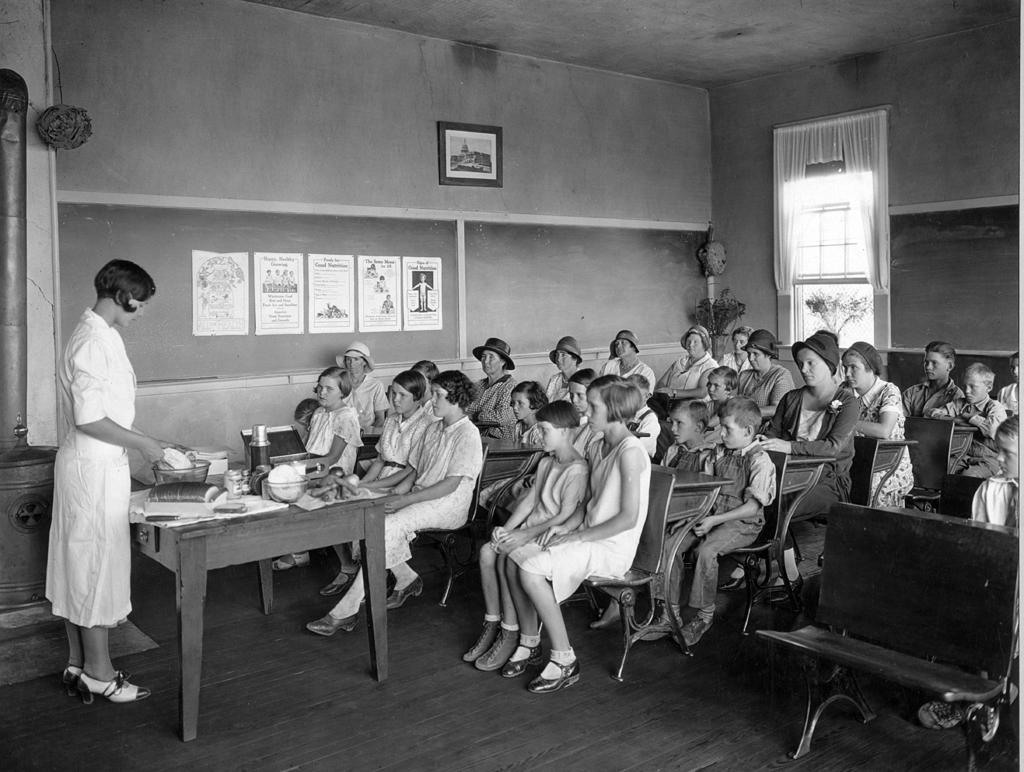What is happening in the image involving a group of people? There is a group of people in the image, and they are sitting on chairs. What are the people in the image focused on? The people are paying attention to a woman in the image. Where is the woman located in the image? The woman is standing on the left side of the image. What type of vessel is being used by the woman in the image? There is no vessel present in the image; the woman is standing and not using any vessel. Can you tell me how many teeth the woman has in the image? It is not possible to determine the number of teeth the woman has in the image, as it does not show her teeth. 